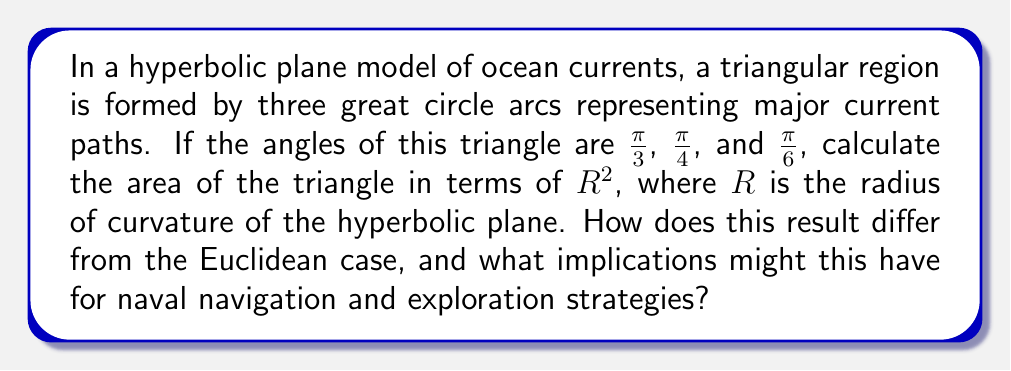Solve this math problem. To solve this problem, we'll follow these steps:

1) Recall the formula for the area of a triangle on a hyperbolic plane:

   $$A = R^2(\pi - (\alpha + \beta + \gamma))$$

   where $A$ is the area, $R$ is the radius of curvature, and $\alpha$, $\beta$, and $\gamma$ are the angles of the triangle.

2) Sum the given angles:

   $$\alpha + \beta + \gamma = \frac{\pi}{3} + \frac{\pi}{4} + \frac{\pi}{6} = \frac{2\pi}{3} + \frac{3\pi}{12} = \frac{8\pi}{12} + \frac{3\pi}{12} = \frac{11\pi}{12}$$

3) Substitute this sum into the area formula:

   $$A = R^2(\pi - \frac{11\pi}{12}) = R^2(\frac{12\pi}{12} - \frac{11\pi}{12}) = R^2(\frac{\pi}{12})$$

4) Simplify:

   $$A = \frac{\pi R^2}{12}$$

5) Compare to the Euclidean case:
   In Euclidean geometry, the sum of angles in a triangle is always $\pi$, resulting in zero area according to this formula. The non-zero area in the hyperbolic case indicates the curvature of the space.

6) Implications for naval exploration:
   This curvature affects distance calculations and optimal path finding. Navigation strategies must account for the hyperbolic nature of the ocean surface, potentially leading to counterintuitive route choices that may be more efficient than traditional "straight line" paths.
Answer: $\frac{\pi R^2}{12}$ 